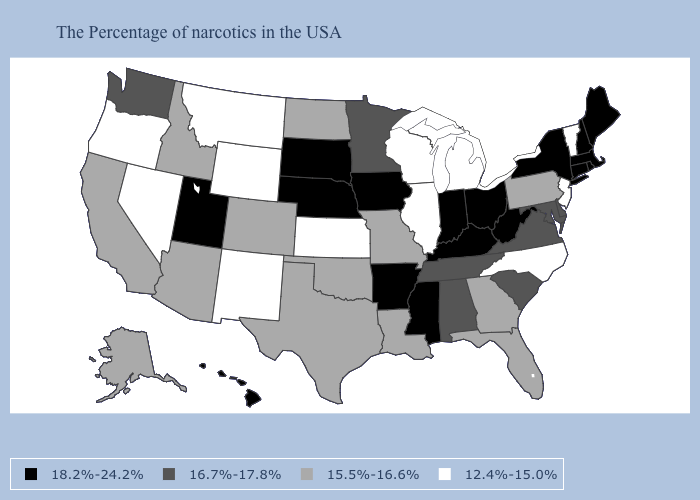Among the states that border Rhode Island , which have the lowest value?
Be succinct. Massachusetts, Connecticut. Does Rhode Island have the same value as Nevada?
Be succinct. No. Among the states that border Colorado , which have the lowest value?
Keep it brief. Kansas, Wyoming, New Mexico. What is the lowest value in the USA?
Write a very short answer. 12.4%-15.0%. Name the states that have a value in the range 16.7%-17.8%?
Write a very short answer. Delaware, Maryland, Virginia, South Carolina, Alabama, Tennessee, Minnesota, Washington. What is the lowest value in the USA?
Give a very brief answer. 12.4%-15.0%. Does the first symbol in the legend represent the smallest category?
Concise answer only. No. Which states have the highest value in the USA?
Give a very brief answer. Maine, Massachusetts, Rhode Island, New Hampshire, Connecticut, New York, West Virginia, Ohio, Kentucky, Indiana, Mississippi, Arkansas, Iowa, Nebraska, South Dakota, Utah, Hawaii. What is the value of Delaware?
Short answer required. 16.7%-17.8%. Which states have the lowest value in the USA?
Give a very brief answer. Vermont, New Jersey, North Carolina, Michigan, Wisconsin, Illinois, Kansas, Wyoming, New Mexico, Montana, Nevada, Oregon. Name the states that have a value in the range 12.4%-15.0%?
Be succinct. Vermont, New Jersey, North Carolina, Michigan, Wisconsin, Illinois, Kansas, Wyoming, New Mexico, Montana, Nevada, Oregon. Which states have the lowest value in the Northeast?
Quick response, please. Vermont, New Jersey. Name the states that have a value in the range 15.5%-16.6%?
Answer briefly. Pennsylvania, Florida, Georgia, Louisiana, Missouri, Oklahoma, Texas, North Dakota, Colorado, Arizona, Idaho, California, Alaska. Name the states that have a value in the range 15.5%-16.6%?
Write a very short answer. Pennsylvania, Florida, Georgia, Louisiana, Missouri, Oklahoma, Texas, North Dakota, Colorado, Arizona, Idaho, California, Alaska. Is the legend a continuous bar?
Short answer required. No. 